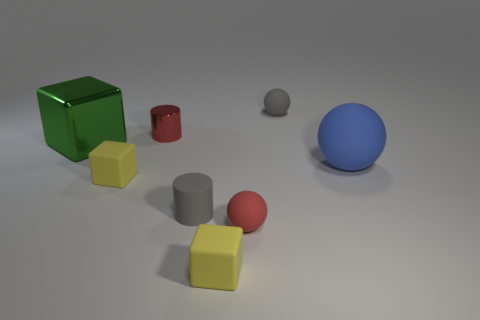There is a blue matte object; is its shape the same as the small gray object to the right of the tiny red sphere?
Make the answer very short. Yes. What is the material of the green thing in front of the tiny red shiny cylinder that is left of the tiny thing that is behind the small red metallic cylinder?
Your answer should be compact. Metal. How many big things are metallic cylinders or spheres?
Provide a succinct answer. 1. What number of other things are there of the same size as the gray cylinder?
Provide a short and direct response. 5. There is a tiny gray matte thing in front of the large green metallic thing; is it the same shape as the red metal thing?
Your response must be concise. Yes. There is a small rubber object that is the same shape as the small red metallic thing; what color is it?
Make the answer very short. Gray. Is the number of small yellow cubes that are left of the tiny shiny cylinder the same as the number of green blocks?
Your answer should be very brief. Yes. How many things are both in front of the large green metallic object and to the right of the red metallic object?
Give a very brief answer. 4. There is a gray rubber object that is the same shape as the big blue object; what is its size?
Ensure brevity in your answer.  Small. How many small red cylinders are the same material as the large green block?
Ensure brevity in your answer.  1. 